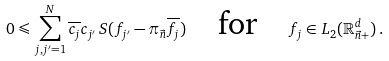<formula> <loc_0><loc_0><loc_500><loc_500>0 \leqslant \sum _ { j , j ^ { \prime } = 1 } ^ { N } \overline { c _ { j } } c _ { j ^ { \prime } } \, S ( f _ { j ^ { \prime } } - \pi _ { \vec { n } } \overline { f _ { j } } ) \quad \text {for} \quad f _ { j } \in L _ { 2 } ( \mathbb { R } ^ { d } _ { \vec { n } + } ) \, .</formula> 